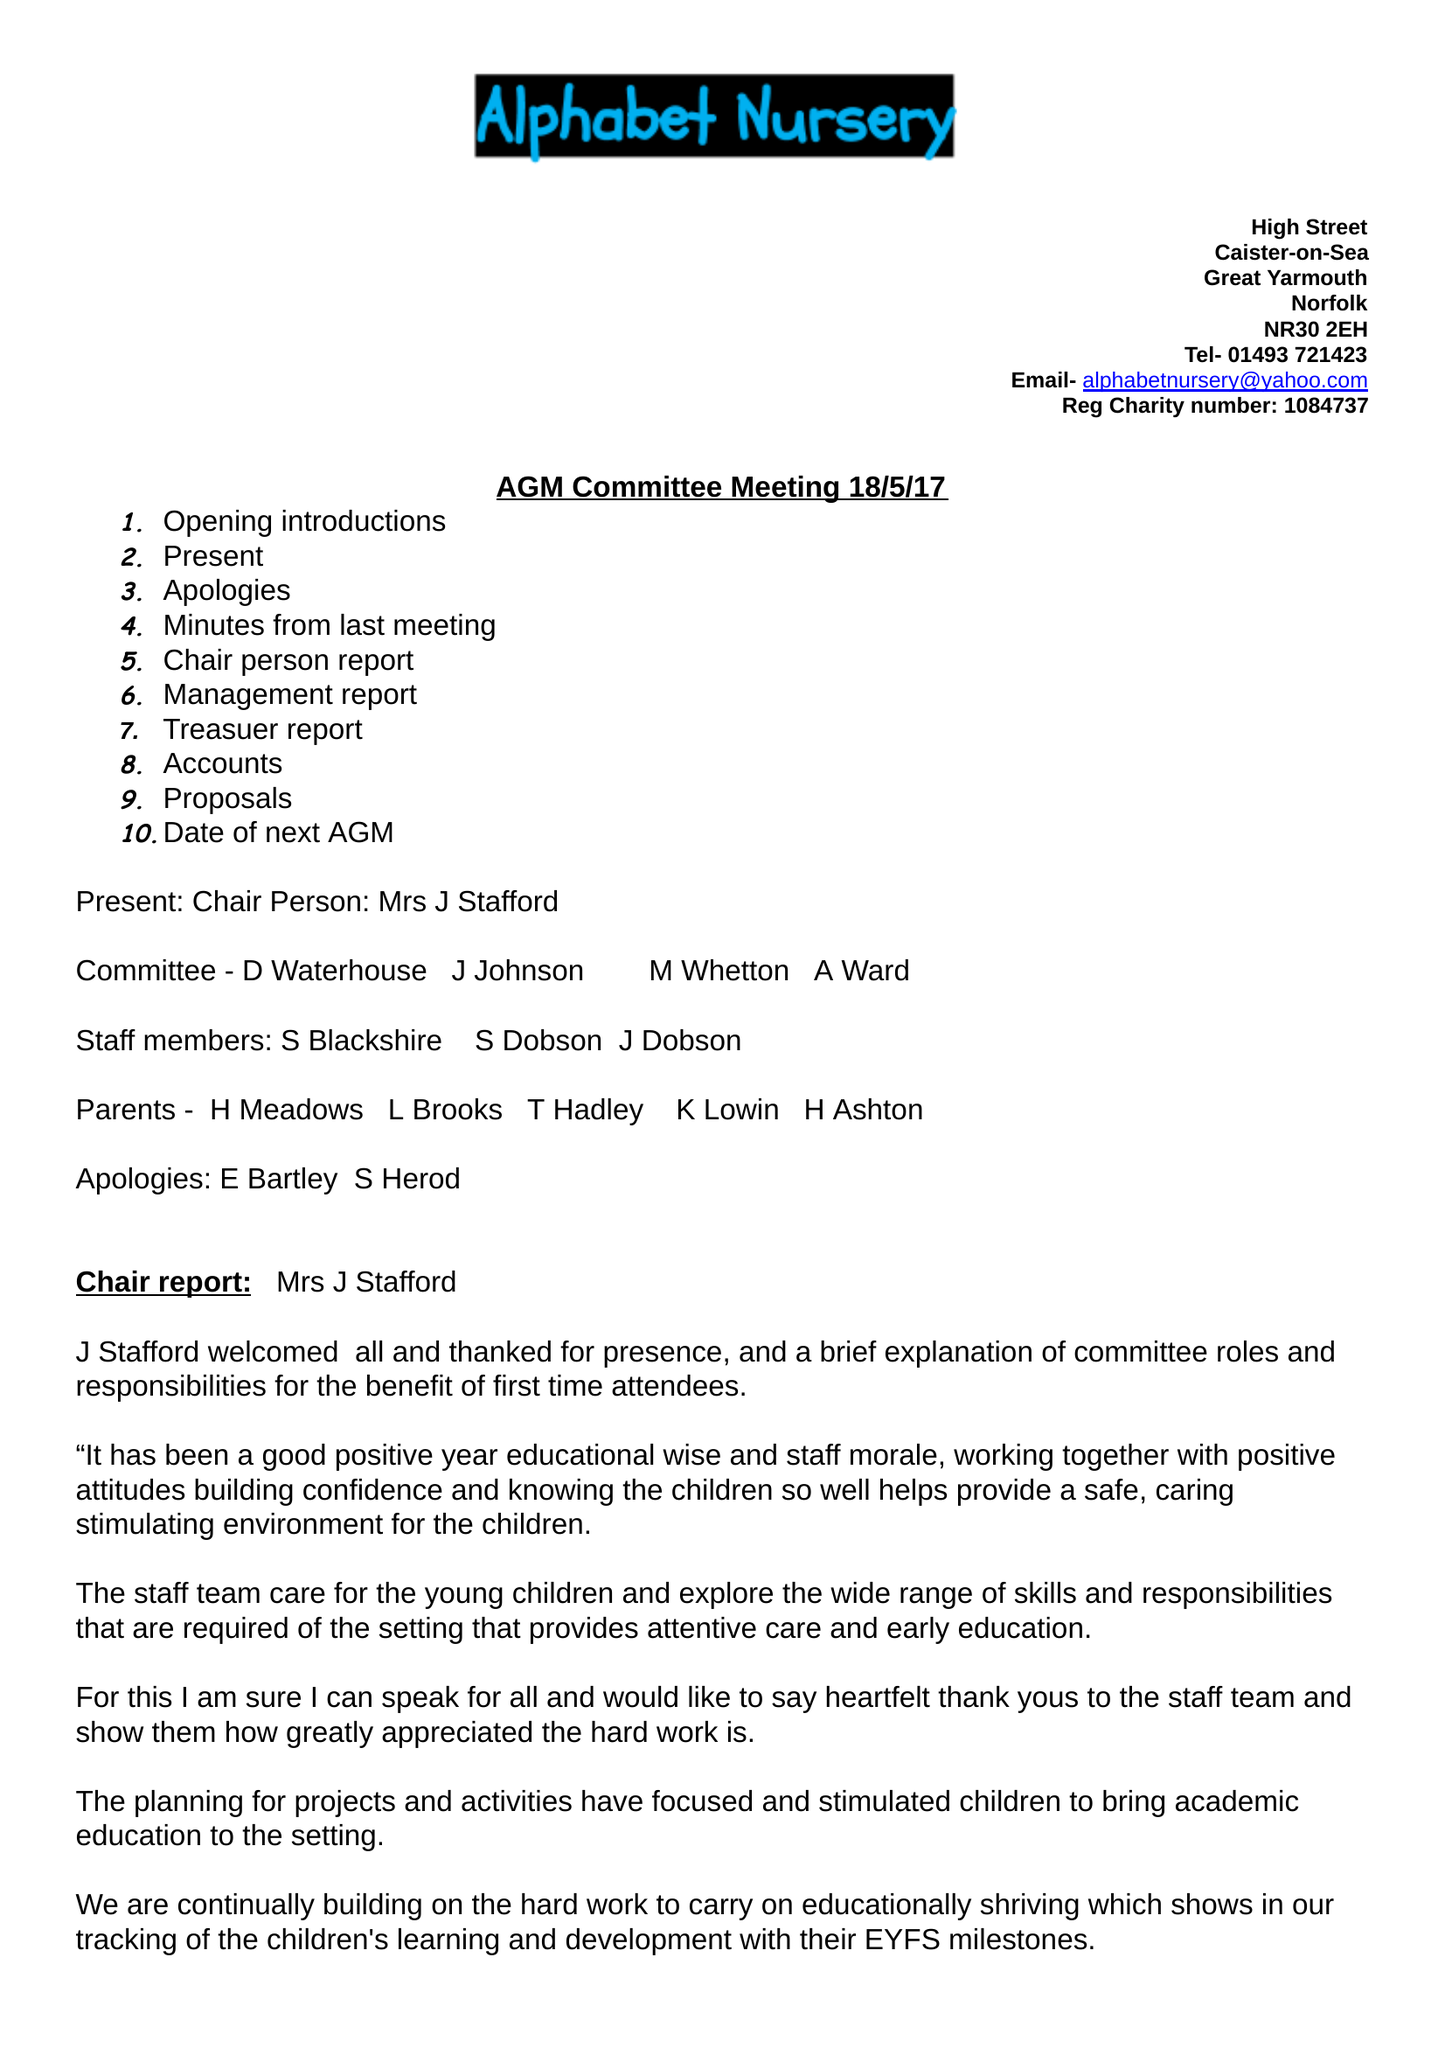What is the value for the charity_number?
Answer the question using a single word or phrase. 1084737 